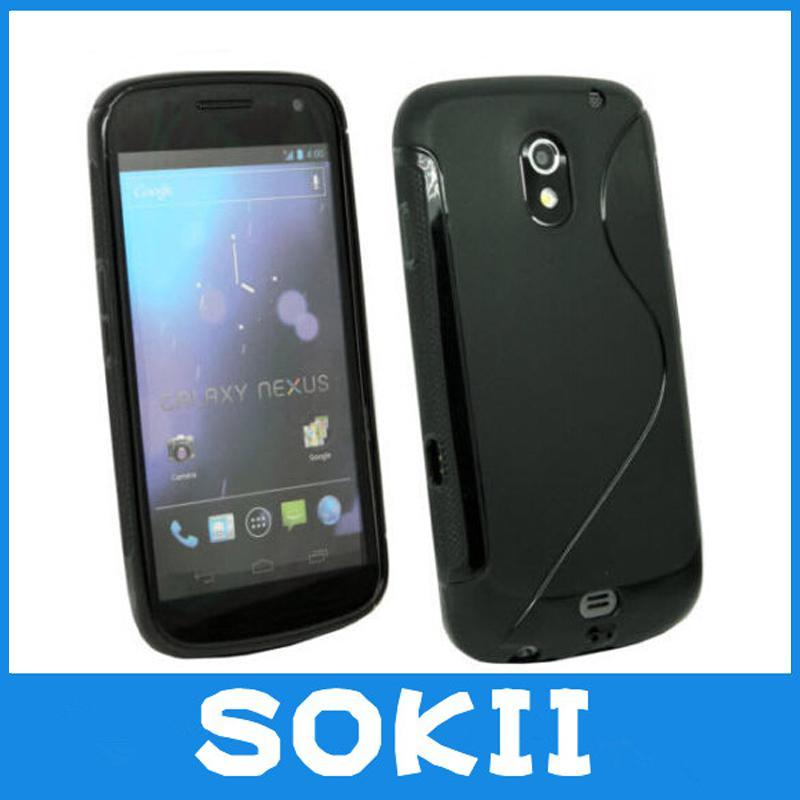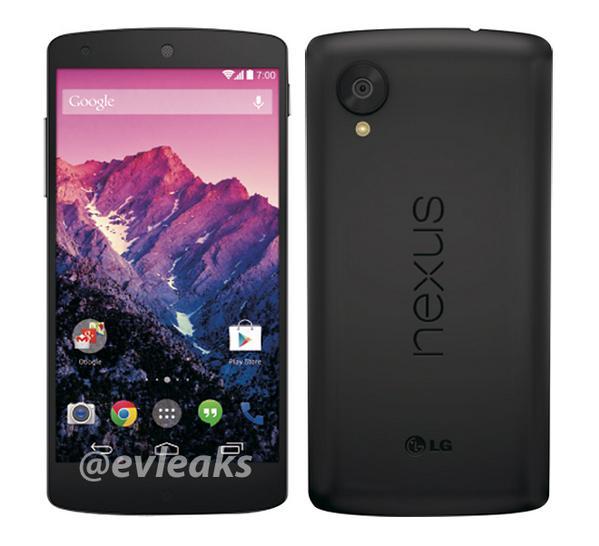The first image is the image on the left, the second image is the image on the right. For the images shown, is this caption "There is no less than five phones." true? Answer yes or no. No. The first image is the image on the left, the second image is the image on the right. Considering the images on both sides, is "There are no less than five phones." valid? Answer yes or no. No. 